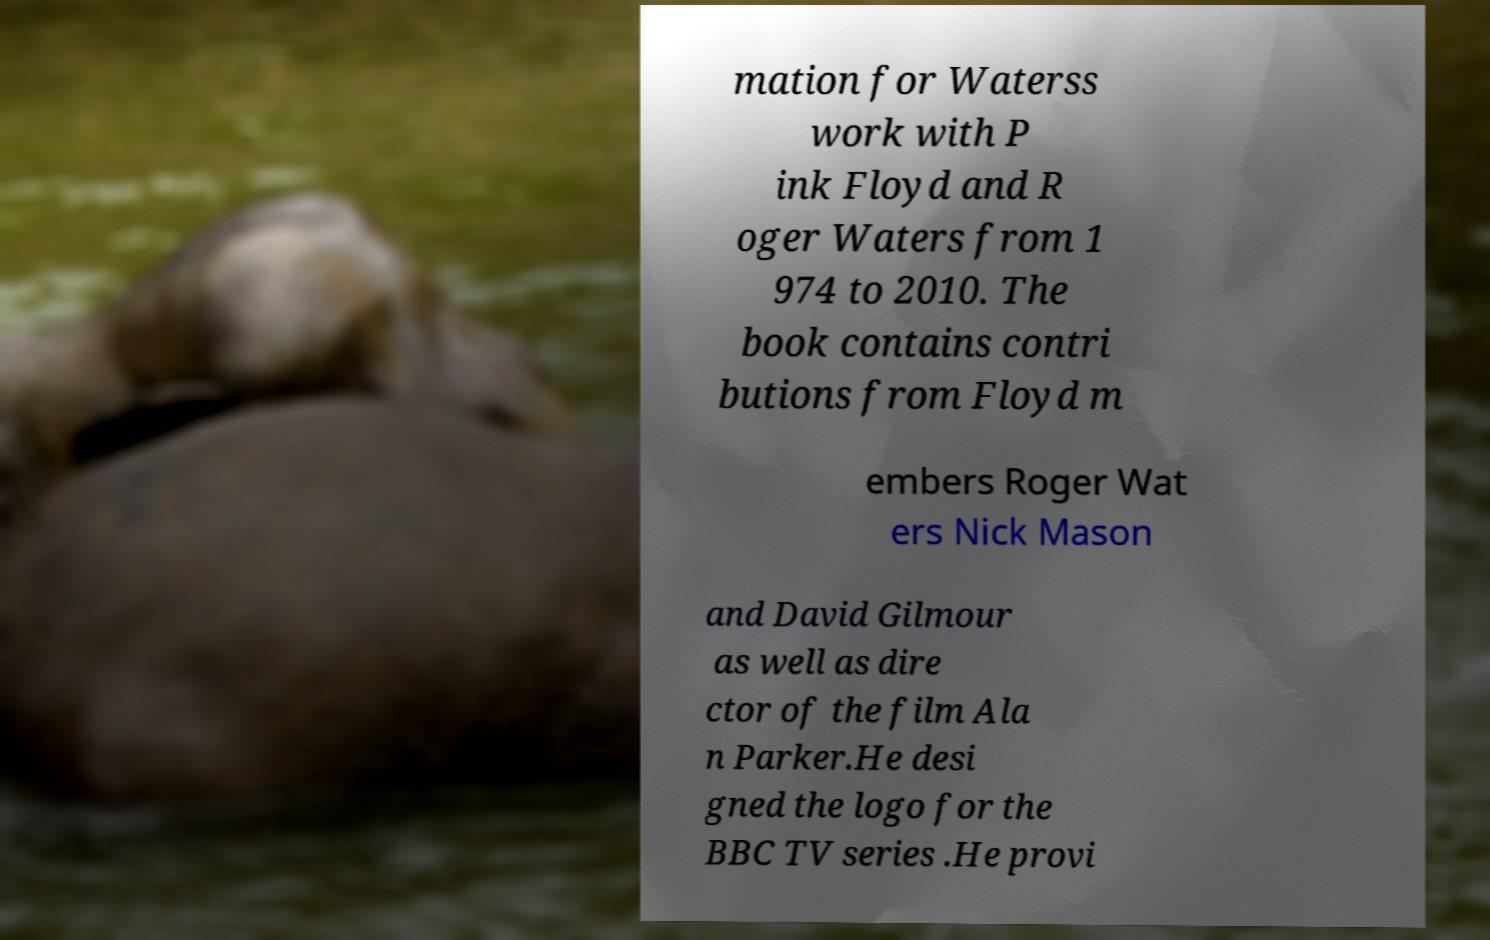Please read and relay the text visible in this image. What does it say? mation for Waterss work with P ink Floyd and R oger Waters from 1 974 to 2010. The book contains contri butions from Floyd m embers Roger Wat ers Nick Mason and David Gilmour as well as dire ctor of the film Ala n Parker.He desi gned the logo for the BBC TV series .He provi 